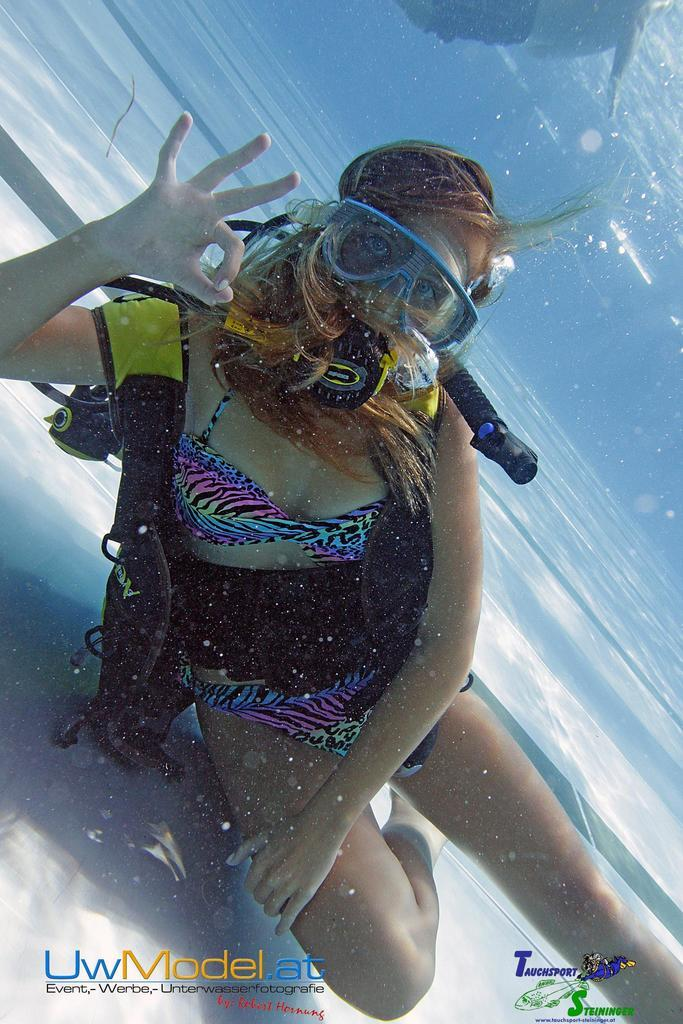Who is present in the image? There is a girl in the image. What is the girl doing in the image? The girl is swimming. Where is the girl located in the image? The girl is in the water. What type of wall can be seen surrounding the girl in the image? There is no wall present in the image; the girl is swimming in the water. How many eggs are visible in the image? There are no eggs present in the image. 